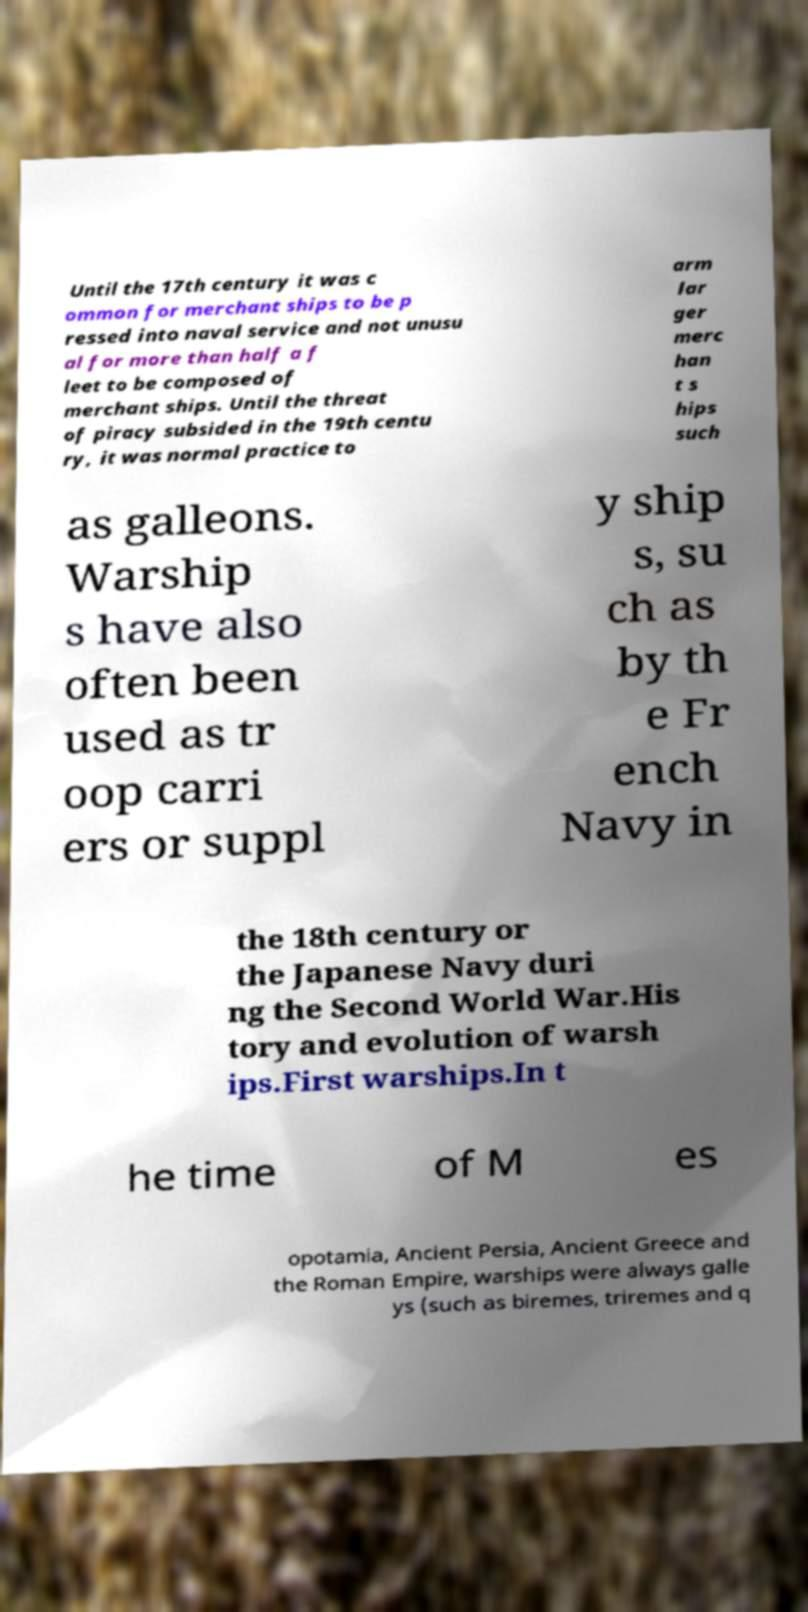Please identify and transcribe the text found in this image. Until the 17th century it was c ommon for merchant ships to be p ressed into naval service and not unusu al for more than half a f leet to be composed of merchant ships. Until the threat of piracy subsided in the 19th centu ry, it was normal practice to arm lar ger merc han t s hips such as galleons. Warship s have also often been used as tr oop carri ers or suppl y ship s, su ch as by th e Fr ench Navy in the 18th century or the Japanese Navy duri ng the Second World War.His tory and evolution of warsh ips.First warships.In t he time of M es opotamia, Ancient Persia, Ancient Greece and the Roman Empire, warships were always galle ys (such as biremes, triremes and q 